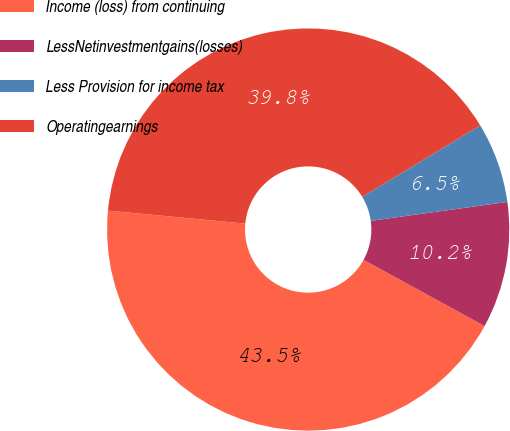Convert chart to OTSL. <chart><loc_0><loc_0><loc_500><loc_500><pie_chart><fcel>Income (loss) from continuing<fcel>LessNetinvestmentgains(losses)<fcel>Less Provision for income tax<fcel>Operatingearnings<nl><fcel>43.53%<fcel>10.16%<fcel>6.47%<fcel>39.84%<nl></chart> 